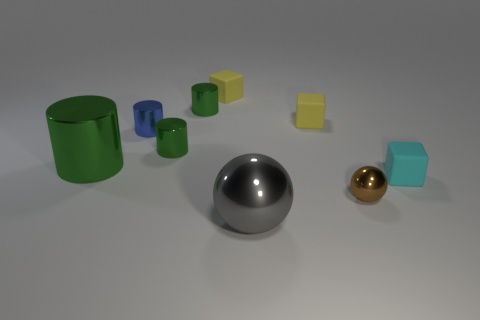Subtract all small shiny cylinders. How many cylinders are left? 1 Add 1 gray metal things. How many objects exist? 10 Subtract all yellow cubes. How many cubes are left? 1 Subtract all yellow cylinders. How many yellow cubes are left? 2 Subtract all cylinders. How many objects are left? 5 Add 7 yellow objects. How many yellow objects are left? 9 Add 1 green cylinders. How many green cylinders exist? 4 Subtract 1 gray spheres. How many objects are left? 8 Subtract 3 cubes. How many cubes are left? 0 Subtract all blue spheres. Subtract all green cylinders. How many spheres are left? 2 